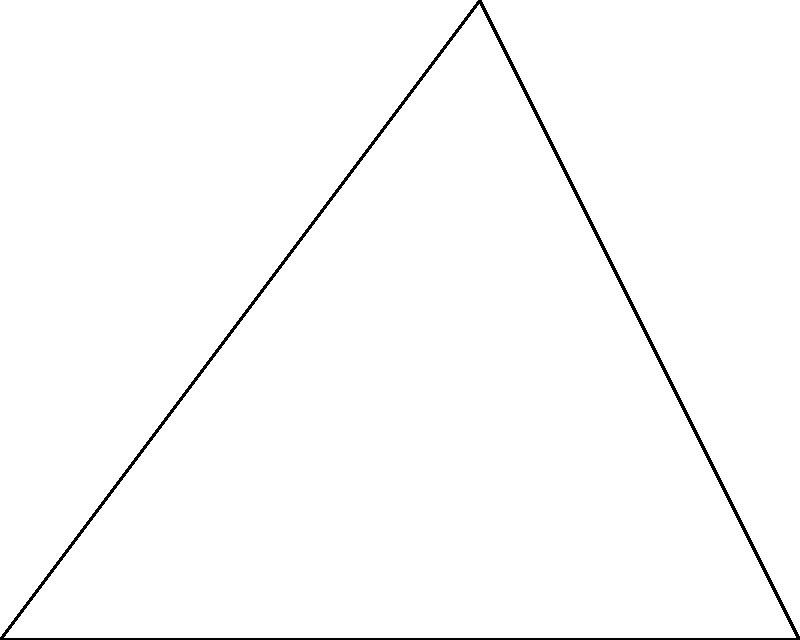In the context of optimizing database queries using vector projection, consider a query vector A(3,4) and an index vector B(5,0). What is the length of the projection of the query vector onto the index vector, and how does this relate to query optimization? To solve this problem and understand its relevance to database query optimization, let's follow these steps:

1. Vector projection formula:
   The projection of vector A onto vector B is given by:
   $$\text{proj}_B A = \frac{A \cdot B}{||B||^2} B$$

2. Calculate the dot product of A and B:
   $$A \cdot B = (3,4) \cdot (5,0) = 3 * 5 + 4 * 0 = 15$$

3. Calculate the magnitude of B squared:
   $$||B||^2 = 5^2 + 0^2 = 25$$

4. Apply the projection formula:
   $$\text{proj}_B A = \frac{15}{25} (5,0) = (3,0)$$

5. Calculate the length of the projection:
   $$||\text{proj}_B A|| = 3$$

6. Interpretation in database query optimization:
   - The query vector represents a multi-dimensional query.
   - The index vector represents an available index in the database.
   - The projection length indicates how well the index aligns with the query.
   - A longer projection suggests the index is more relevant to the query.
   - In this case, the projection length of 3 out of a possible 5 (the length of the index vector) indicates a moderate alignment between the query and the index.
   - This information can be used to decide whether to use this index for the query or consider alternative indexing strategies.
Answer: 3 (moderate alignment, suggesting potential use of the index for query optimization) 